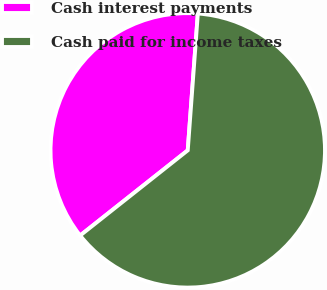Convert chart to OTSL. <chart><loc_0><loc_0><loc_500><loc_500><pie_chart><fcel>Cash interest payments<fcel>Cash paid for income taxes<nl><fcel>36.83%<fcel>63.17%<nl></chart> 